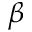<formula> <loc_0><loc_0><loc_500><loc_500>\beta</formula> 